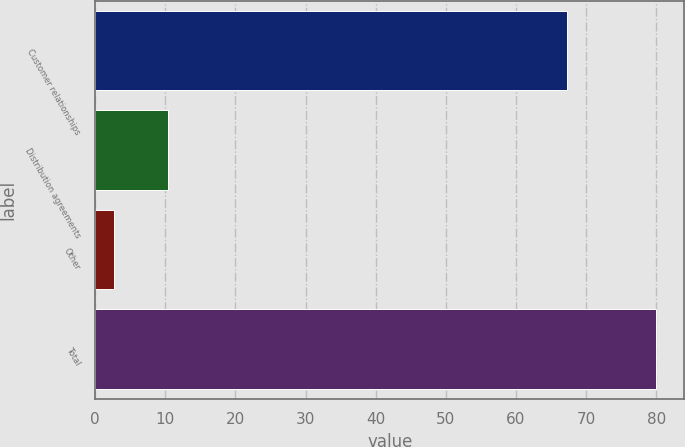Convert chart to OTSL. <chart><loc_0><loc_0><loc_500><loc_500><bar_chart><fcel>Customer relationships<fcel>Distribution agreements<fcel>Other<fcel>Total<nl><fcel>67.3<fcel>10.43<fcel>2.7<fcel>80<nl></chart> 